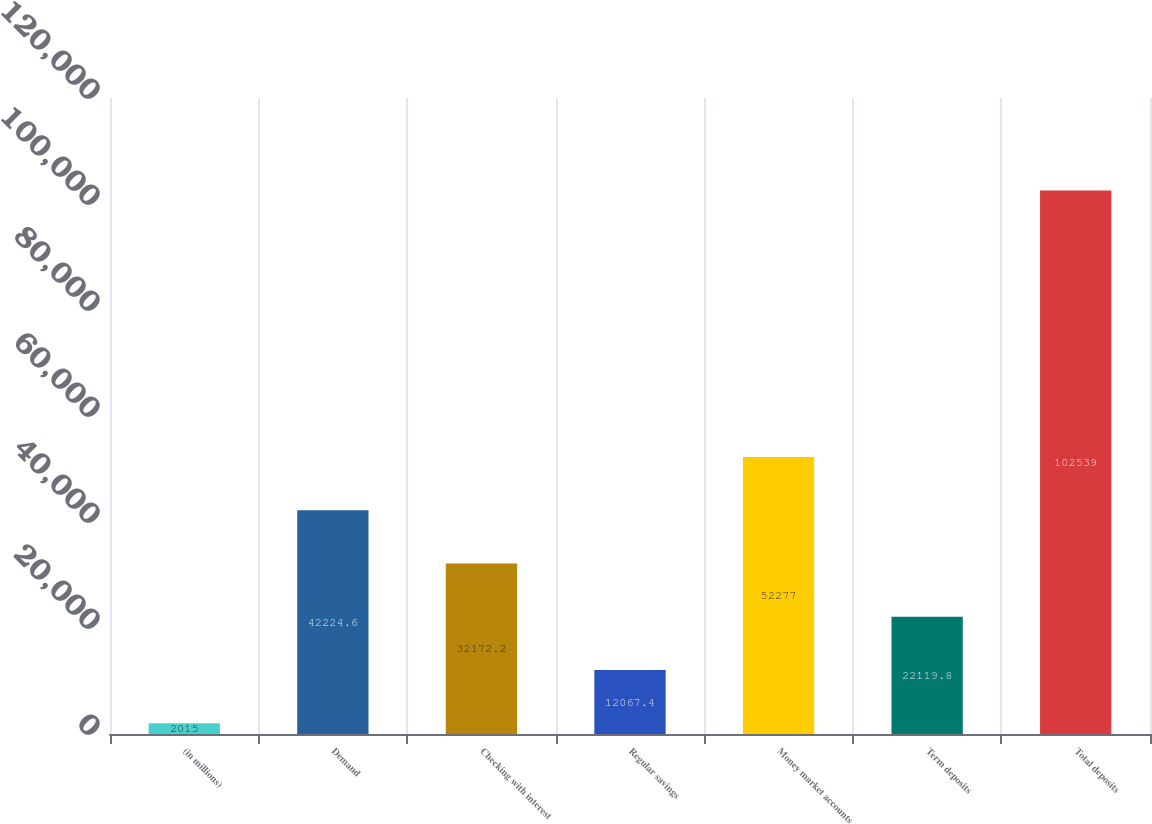<chart> <loc_0><loc_0><loc_500><loc_500><bar_chart><fcel>(in millions)<fcel>Demand<fcel>Checking with interest<fcel>Regular savings<fcel>Money market accounts<fcel>Term deposits<fcel>Total deposits<nl><fcel>2015<fcel>42224.6<fcel>32172.2<fcel>12067.4<fcel>52277<fcel>22119.8<fcel>102539<nl></chart> 